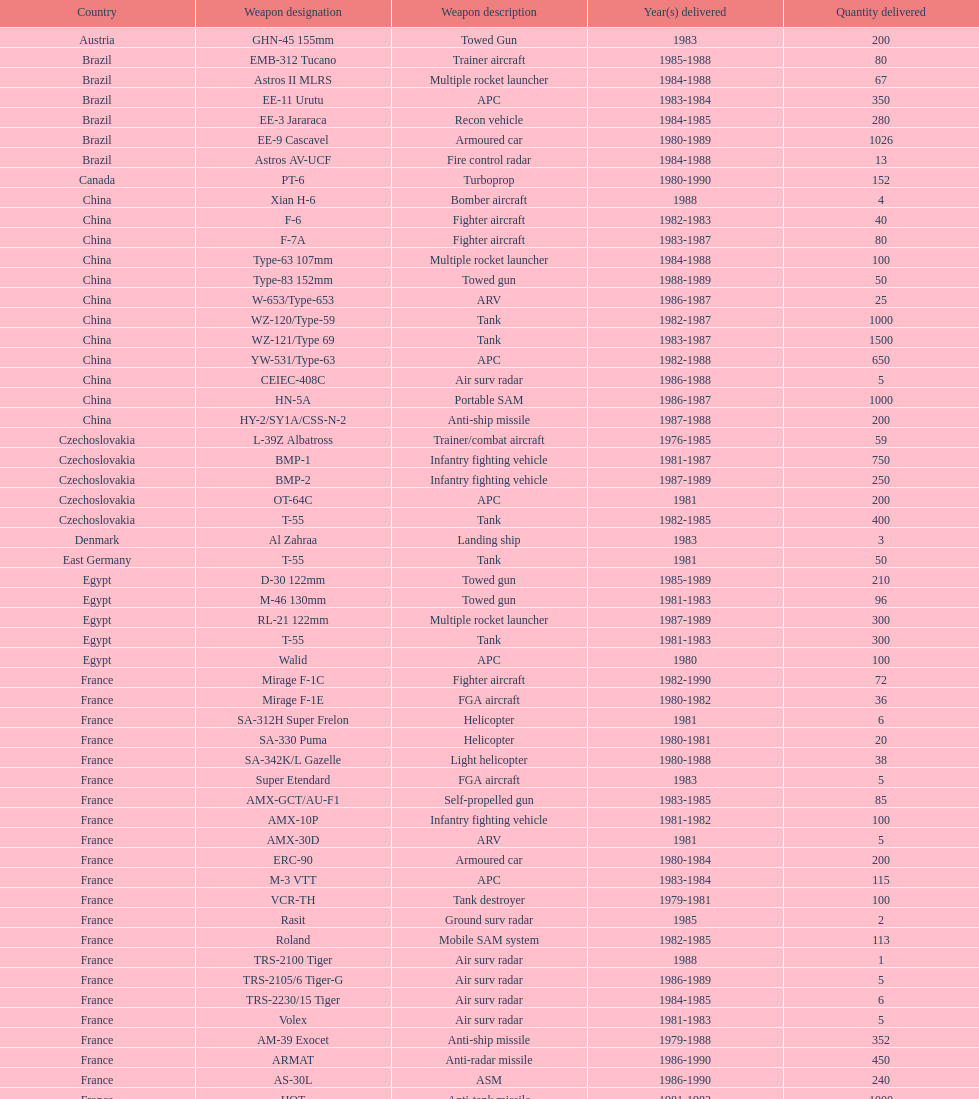Which country obtained the greatest number of towed weapons? Soviet Union. 